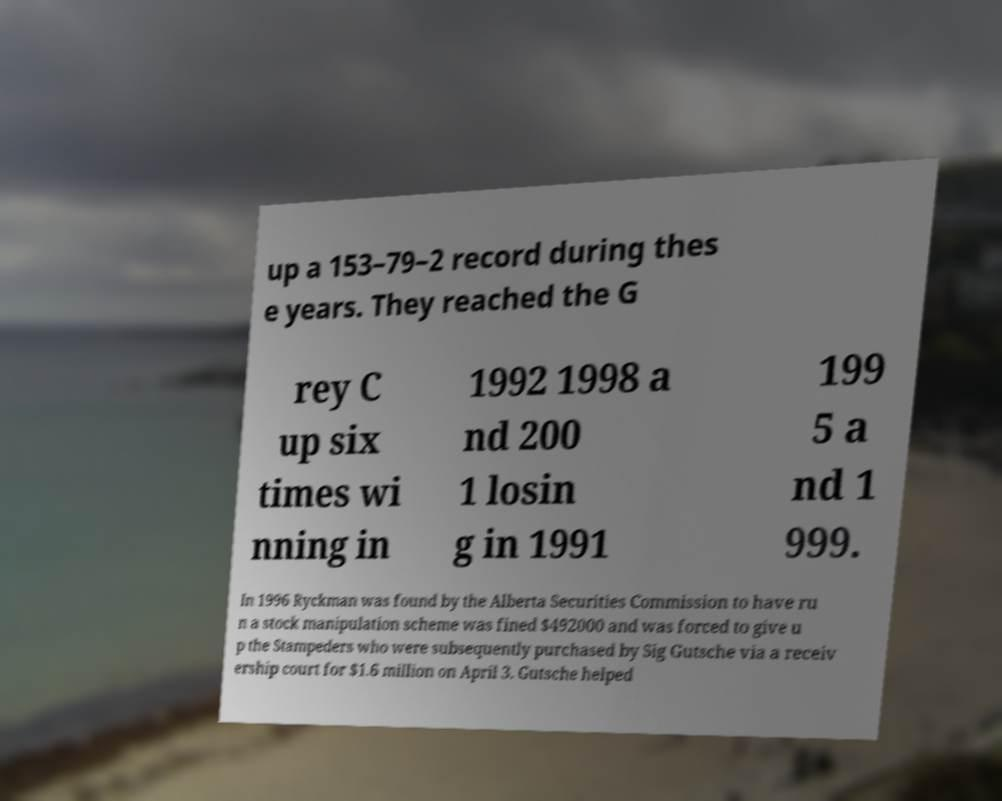Please identify and transcribe the text found in this image. up a 153–79–2 record during thes e years. They reached the G rey C up six times wi nning in 1992 1998 a nd 200 1 losin g in 1991 199 5 a nd 1 999. In 1996 Ryckman was found by the Alberta Securities Commission to have ru n a stock manipulation scheme was fined $492000 and was forced to give u p the Stampeders who were subsequently purchased by Sig Gutsche via a receiv ership court for $1.6 million on April 3. Gutsche helped 